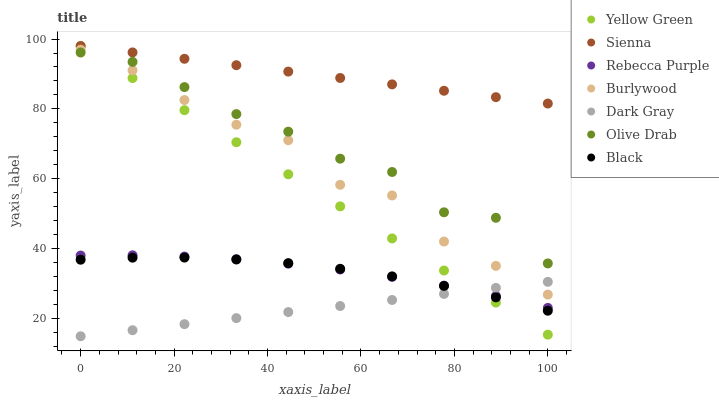Does Dark Gray have the minimum area under the curve?
Answer yes or no. Yes. Does Sienna have the maximum area under the curve?
Answer yes or no. Yes. Does Yellow Green have the minimum area under the curve?
Answer yes or no. No. Does Yellow Green have the maximum area under the curve?
Answer yes or no. No. Is Dark Gray the smoothest?
Answer yes or no. Yes. Is Olive Drab the roughest?
Answer yes or no. Yes. Is Yellow Green the smoothest?
Answer yes or no. No. Is Yellow Green the roughest?
Answer yes or no. No. Does Dark Gray have the lowest value?
Answer yes or no. Yes. Does Yellow Green have the lowest value?
Answer yes or no. No. Does Sienna have the highest value?
Answer yes or no. Yes. Does Burlywood have the highest value?
Answer yes or no. No. Is Black less than Burlywood?
Answer yes or no. Yes. Is Burlywood greater than Black?
Answer yes or no. Yes. Does Dark Gray intersect Rebecca Purple?
Answer yes or no. Yes. Is Dark Gray less than Rebecca Purple?
Answer yes or no. No. Is Dark Gray greater than Rebecca Purple?
Answer yes or no. No. Does Black intersect Burlywood?
Answer yes or no. No. 